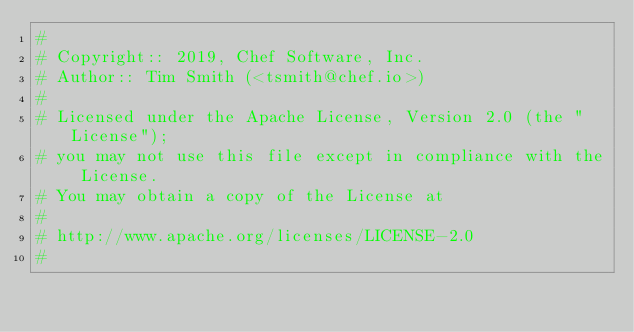<code> <loc_0><loc_0><loc_500><loc_500><_Ruby_>#
# Copyright:: 2019, Chef Software, Inc.
# Author:: Tim Smith (<tsmith@chef.io>)
#
# Licensed under the Apache License, Version 2.0 (the "License");
# you may not use this file except in compliance with the License.
# You may obtain a copy of the License at
#
# http://www.apache.org/licenses/LICENSE-2.0
#</code> 